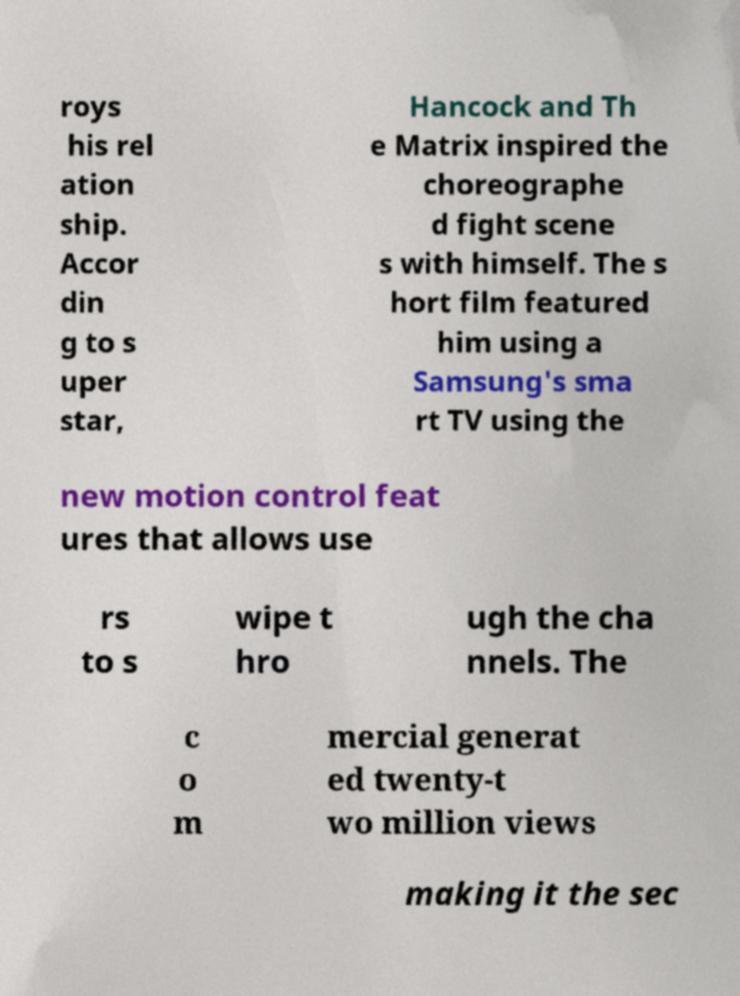Could you assist in decoding the text presented in this image and type it out clearly? roys his rel ation ship. Accor din g to s uper star, Hancock and Th e Matrix inspired the choreographe d fight scene s with himself. The s hort film featured him using a Samsung's sma rt TV using the new motion control feat ures that allows use rs to s wipe t hro ugh the cha nnels. The c o m mercial generat ed twenty-t wo million views making it the sec 